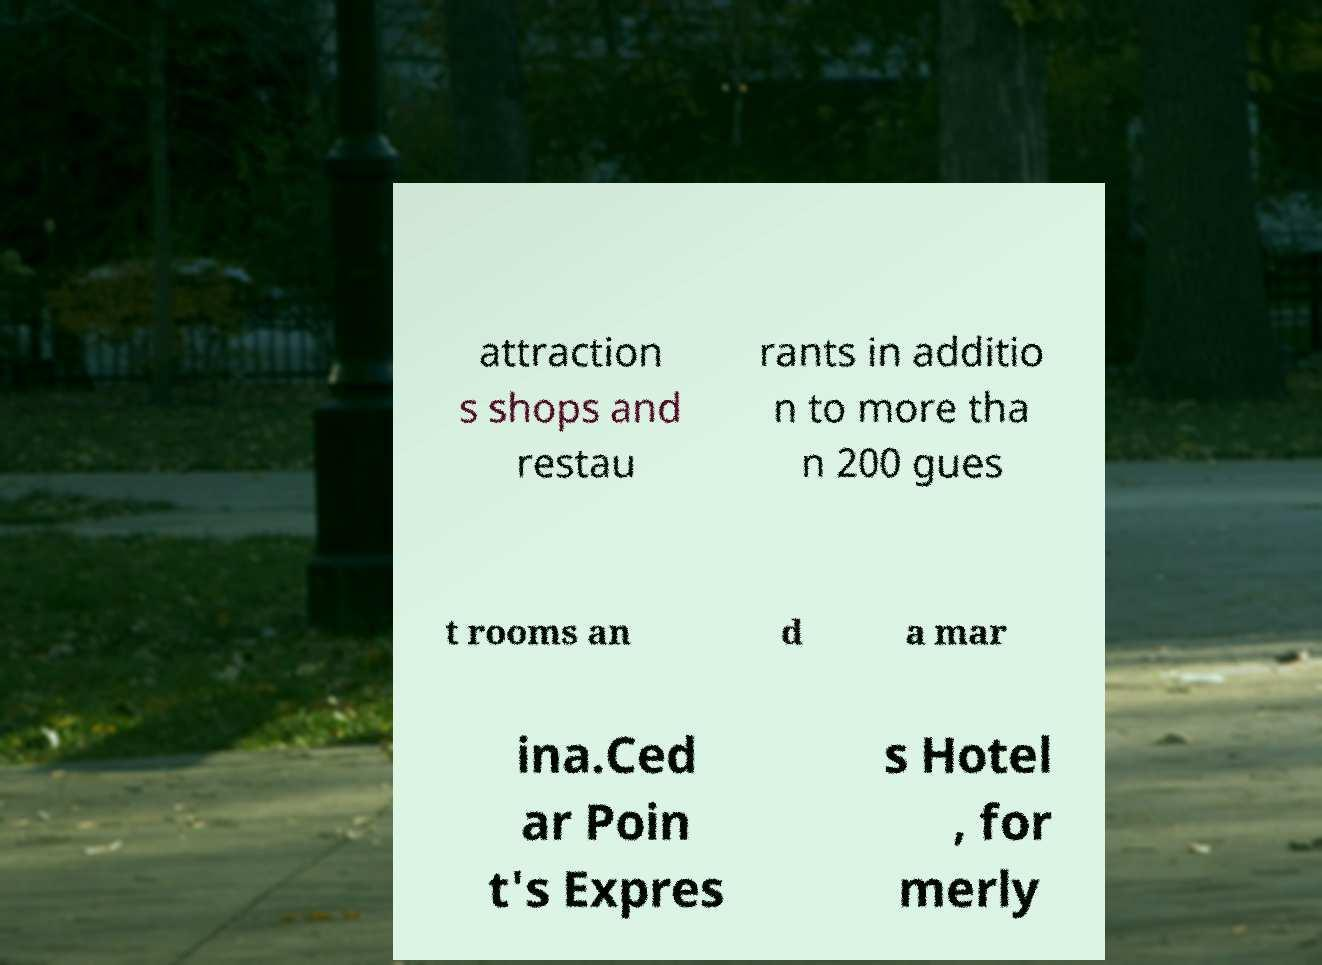Can you accurately transcribe the text from the provided image for me? attraction s shops and restau rants in additio n to more tha n 200 gues t rooms an d a mar ina.Ced ar Poin t's Expres s Hotel , for merly 